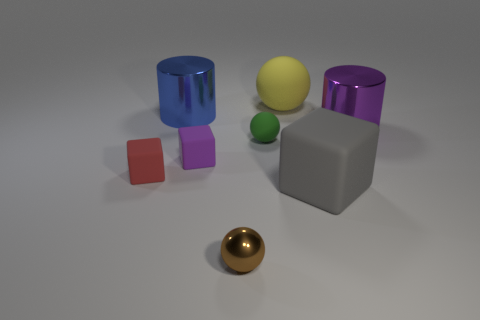Add 2 large yellow spheres. How many objects exist? 10 Subtract all spheres. How many objects are left? 5 Add 6 brown balls. How many brown balls are left? 7 Add 4 purple matte things. How many purple matte things exist? 5 Subtract 0 brown cylinders. How many objects are left? 8 Subtract all large blue cubes. Subtract all green things. How many objects are left? 7 